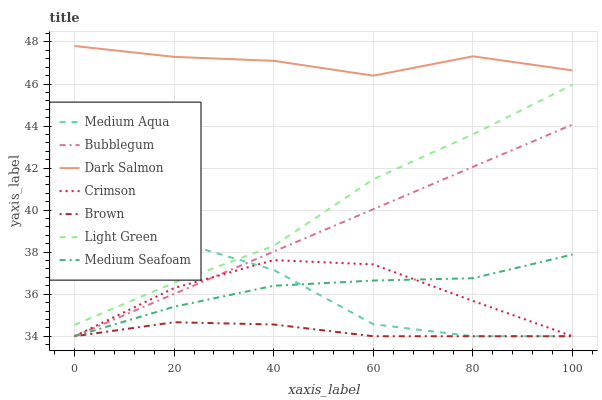Does Brown have the minimum area under the curve?
Answer yes or no. Yes. Does Dark Salmon have the maximum area under the curve?
Answer yes or no. Yes. Does Bubblegum have the minimum area under the curve?
Answer yes or no. No. Does Bubblegum have the maximum area under the curve?
Answer yes or no. No. Is Bubblegum the smoothest?
Answer yes or no. Yes. Is Medium Aqua the roughest?
Answer yes or no. Yes. Is Dark Salmon the smoothest?
Answer yes or no. No. Is Dark Salmon the roughest?
Answer yes or no. No. Does Brown have the lowest value?
Answer yes or no. Yes. Does Dark Salmon have the lowest value?
Answer yes or no. No. Does Dark Salmon have the highest value?
Answer yes or no. Yes. Does Bubblegum have the highest value?
Answer yes or no. No. Is Medium Seafoam less than Light Green?
Answer yes or no. Yes. Is Dark Salmon greater than Bubblegum?
Answer yes or no. Yes. Does Brown intersect Crimson?
Answer yes or no. Yes. Is Brown less than Crimson?
Answer yes or no. No. Is Brown greater than Crimson?
Answer yes or no. No. Does Medium Seafoam intersect Light Green?
Answer yes or no. No. 